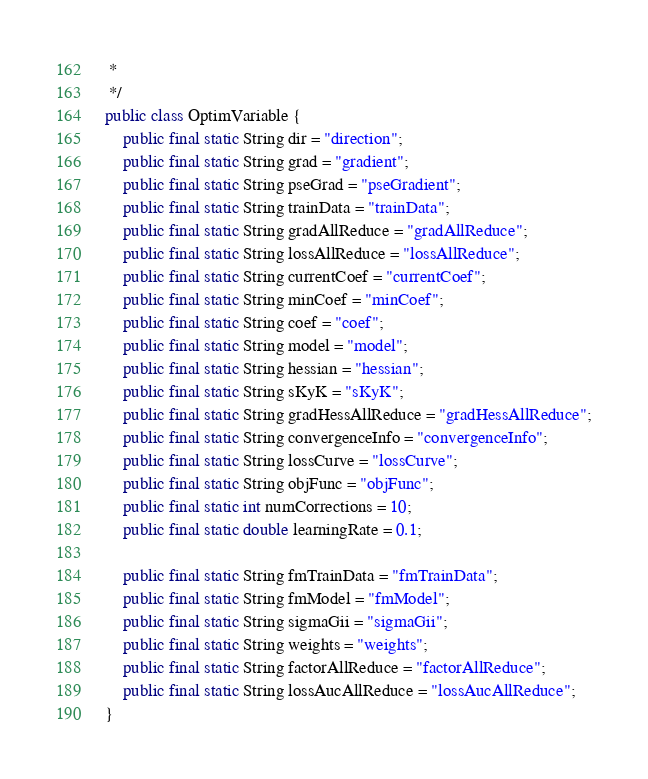Convert code to text. <code><loc_0><loc_0><loc_500><loc_500><_Java_> *
 */
public class OptimVariable {
    public final static String dir = "direction";
    public final static String grad = "gradient";
    public final static String pseGrad = "pseGradient";
    public final static String trainData = "trainData";
    public final static String gradAllReduce = "gradAllReduce";
    public final static String lossAllReduce = "lossAllReduce";
    public final static String currentCoef = "currentCoef";
    public final static String minCoef = "minCoef";
    public final static String coef = "coef";
    public final static String model = "model";
    public final static String hessian = "hessian";
    public final static String sKyK = "sKyK";
    public final static String gradHessAllReduce = "gradHessAllReduce";
    public final static String convergenceInfo = "convergenceInfo";
    public final static String lossCurve = "lossCurve";
    public final static String objFunc = "objFunc";
    public final static int numCorrections = 10;
    public final static double learningRate = 0.1;

    public final static String fmTrainData = "fmTrainData";
    public final static String fmModel = "fmModel";
    public final static String sigmaGii = "sigmaGii";
    public final static String weights = "weights";
    public final static String factorAllReduce = "factorAllReduce";
    public final static String lossAucAllReduce = "lossAucAllReduce";
}
</code> 